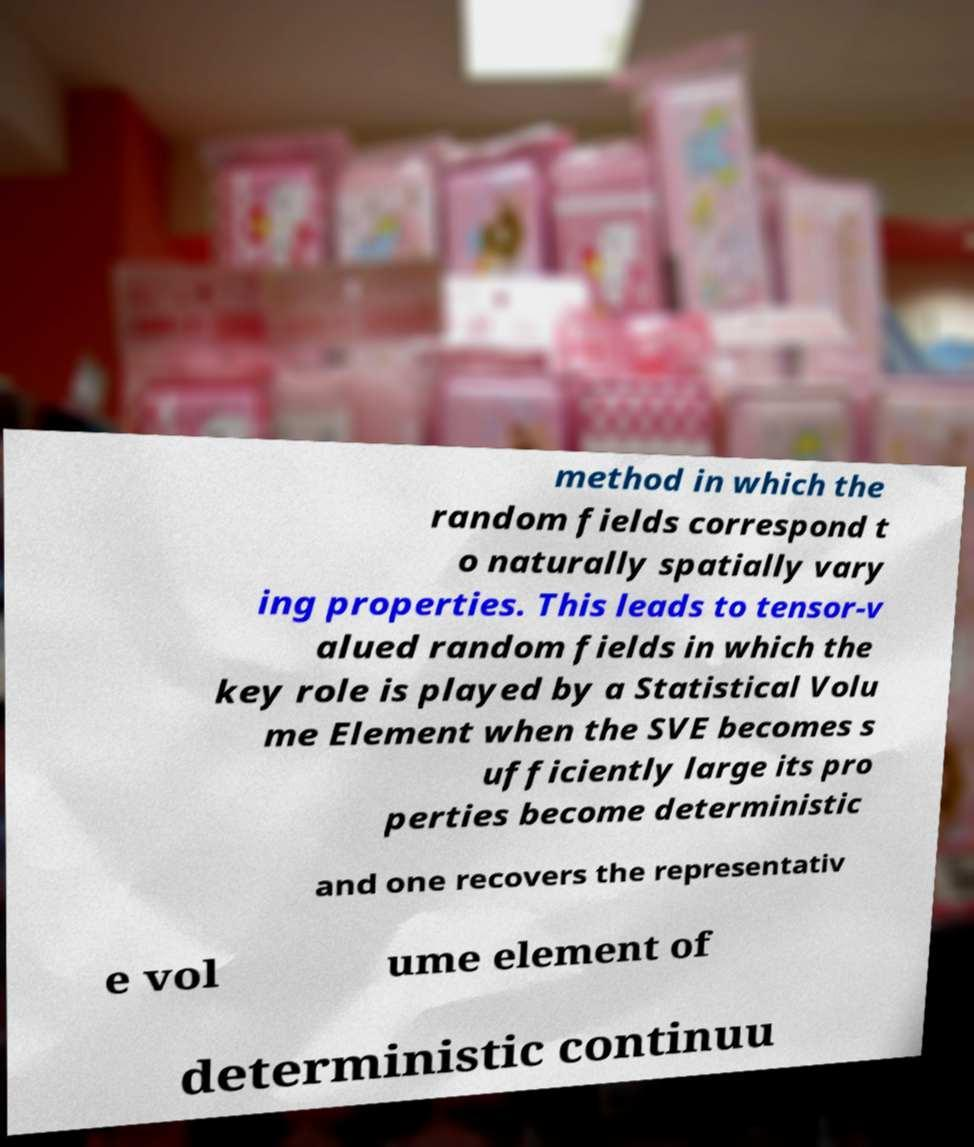Could you extract and type out the text from this image? method in which the random fields correspond t o naturally spatially vary ing properties. This leads to tensor-v alued random fields in which the key role is played by a Statistical Volu me Element when the SVE becomes s ufficiently large its pro perties become deterministic and one recovers the representativ e vol ume element of deterministic continuu 